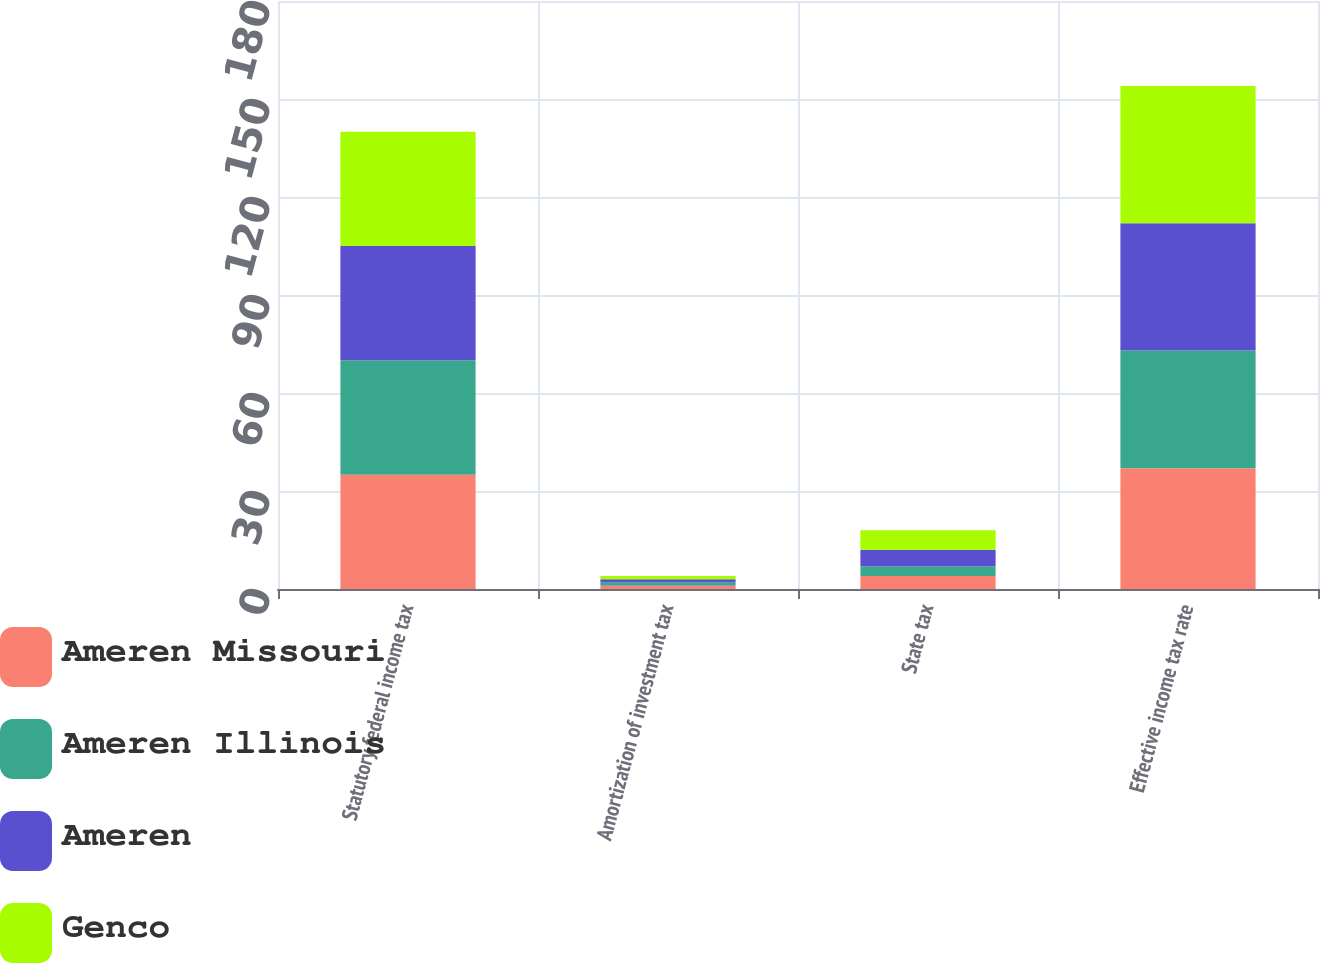<chart> <loc_0><loc_0><loc_500><loc_500><stacked_bar_chart><ecel><fcel>Statutory federal income tax<fcel>Amortization of investment tax<fcel>State tax<fcel>Effective income tax rate<nl><fcel>Ameren Missouri<fcel>35<fcel>1<fcel>4<fcel>37<nl><fcel>Ameren Illinois<fcel>35<fcel>1<fcel>3<fcel>36<nl><fcel>Ameren<fcel>35<fcel>1<fcel>5<fcel>39<nl><fcel>Genco<fcel>35<fcel>1<fcel>6<fcel>42<nl></chart> 